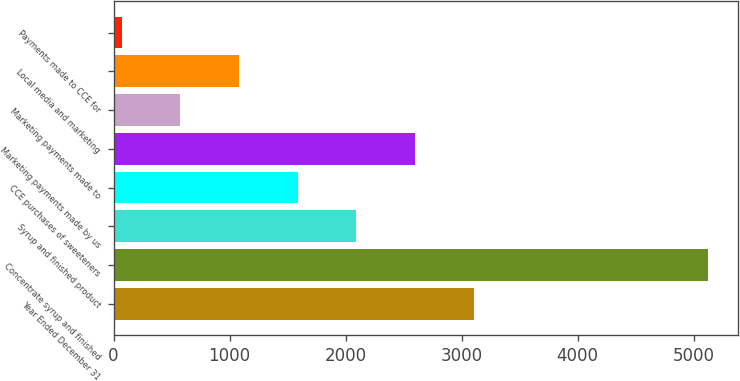<chart> <loc_0><loc_0><loc_500><loc_500><bar_chart><fcel>Year Ended December 31<fcel>Concentrate syrup and finished<fcel>Syrup and finished product<fcel>CCE purchases of sweeteners<fcel>Marketing payments made by us<fcel>Marketing payments made to<fcel>Local media and marketing<fcel>Payments made to CCE for<nl><fcel>3103<fcel>5125<fcel>2092<fcel>1586.5<fcel>2597.5<fcel>575.5<fcel>1081<fcel>70<nl></chart> 